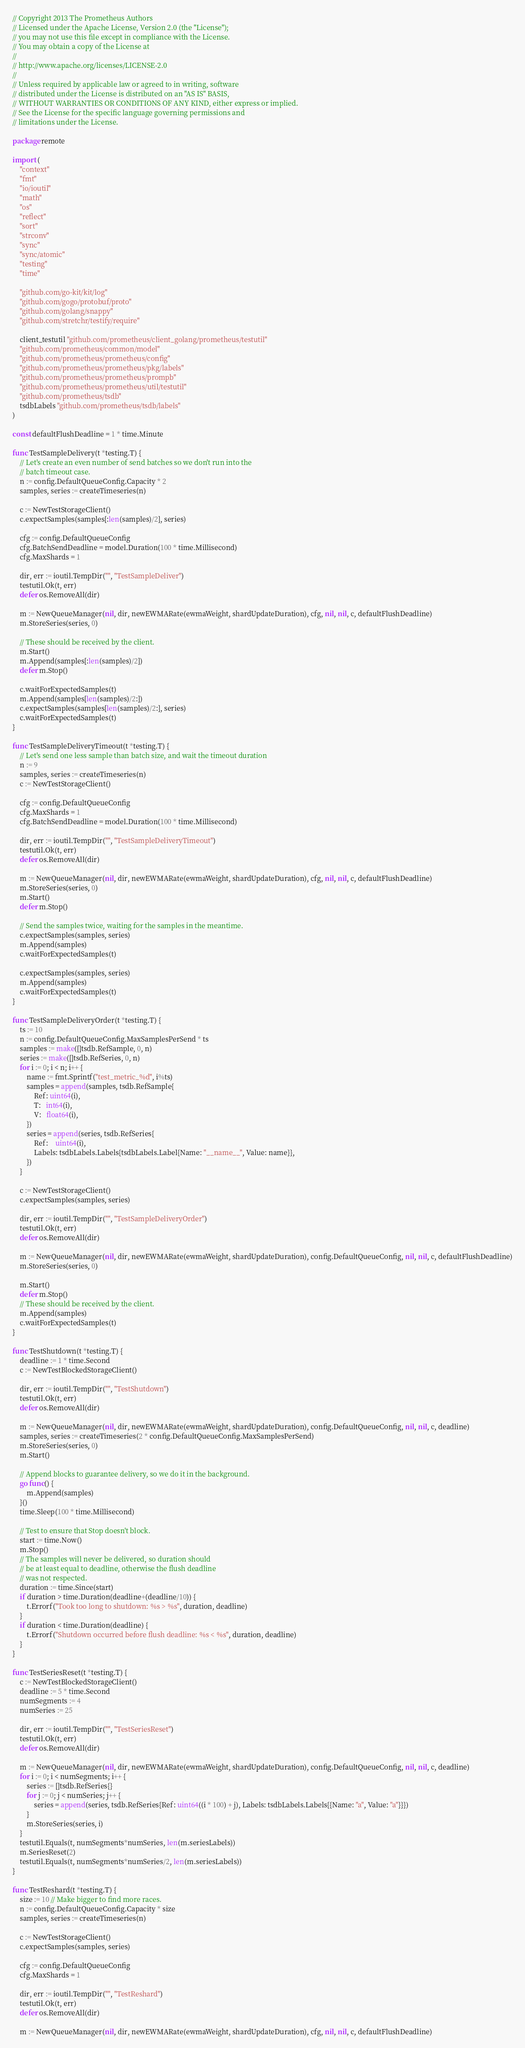<code> <loc_0><loc_0><loc_500><loc_500><_Go_>// Copyright 2013 The Prometheus Authors
// Licensed under the Apache License, Version 2.0 (the "License");
// you may not use this file except in compliance with the License.
// You may obtain a copy of the License at
//
// http://www.apache.org/licenses/LICENSE-2.0
//
// Unless required by applicable law or agreed to in writing, software
// distributed under the License is distributed on an "AS IS" BASIS,
// WITHOUT WARRANTIES OR CONDITIONS OF ANY KIND, either express or implied.
// See the License for the specific language governing permissions and
// limitations under the License.

package remote

import (
	"context"
	"fmt"
	"io/ioutil"
	"math"
	"os"
	"reflect"
	"sort"
	"strconv"
	"sync"
	"sync/atomic"
	"testing"
	"time"

	"github.com/go-kit/kit/log"
	"github.com/gogo/protobuf/proto"
	"github.com/golang/snappy"
	"github.com/stretchr/testify/require"

	client_testutil "github.com/prometheus/client_golang/prometheus/testutil"
	"github.com/prometheus/common/model"
	"github.com/prometheus/prometheus/config"
	"github.com/prometheus/prometheus/pkg/labels"
	"github.com/prometheus/prometheus/prompb"
	"github.com/prometheus/prometheus/util/testutil"
	"github.com/prometheus/tsdb"
	tsdbLabels "github.com/prometheus/tsdb/labels"
)

const defaultFlushDeadline = 1 * time.Minute

func TestSampleDelivery(t *testing.T) {
	// Let's create an even number of send batches so we don't run into the
	// batch timeout case.
	n := config.DefaultQueueConfig.Capacity * 2
	samples, series := createTimeseries(n)

	c := NewTestStorageClient()
	c.expectSamples(samples[:len(samples)/2], series)

	cfg := config.DefaultQueueConfig
	cfg.BatchSendDeadline = model.Duration(100 * time.Millisecond)
	cfg.MaxShards = 1

	dir, err := ioutil.TempDir("", "TestSampleDeliver")
	testutil.Ok(t, err)
	defer os.RemoveAll(dir)

	m := NewQueueManager(nil, dir, newEWMARate(ewmaWeight, shardUpdateDuration), cfg, nil, nil, c, defaultFlushDeadline)
	m.StoreSeries(series, 0)

	// These should be received by the client.
	m.Start()
	m.Append(samples[:len(samples)/2])
	defer m.Stop()

	c.waitForExpectedSamples(t)
	m.Append(samples[len(samples)/2:])
	c.expectSamples(samples[len(samples)/2:], series)
	c.waitForExpectedSamples(t)
}

func TestSampleDeliveryTimeout(t *testing.T) {
	// Let's send one less sample than batch size, and wait the timeout duration
	n := 9
	samples, series := createTimeseries(n)
	c := NewTestStorageClient()

	cfg := config.DefaultQueueConfig
	cfg.MaxShards = 1
	cfg.BatchSendDeadline = model.Duration(100 * time.Millisecond)

	dir, err := ioutil.TempDir("", "TestSampleDeliveryTimeout")
	testutil.Ok(t, err)
	defer os.RemoveAll(dir)

	m := NewQueueManager(nil, dir, newEWMARate(ewmaWeight, shardUpdateDuration), cfg, nil, nil, c, defaultFlushDeadline)
	m.StoreSeries(series, 0)
	m.Start()
	defer m.Stop()

	// Send the samples twice, waiting for the samples in the meantime.
	c.expectSamples(samples, series)
	m.Append(samples)
	c.waitForExpectedSamples(t)

	c.expectSamples(samples, series)
	m.Append(samples)
	c.waitForExpectedSamples(t)
}

func TestSampleDeliveryOrder(t *testing.T) {
	ts := 10
	n := config.DefaultQueueConfig.MaxSamplesPerSend * ts
	samples := make([]tsdb.RefSample, 0, n)
	series := make([]tsdb.RefSeries, 0, n)
	for i := 0; i < n; i++ {
		name := fmt.Sprintf("test_metric_%d", i%ts)
		samples = append(samples, tsdb.RefSample{
			Ref: uint64(i),
			T:   int64(i),
			V:   float64(i),
		})
		series = append(series, tsdb.RefSeries{
			Ref:    uint64(i),
			Labels: tsdbLabels.Labels{tsdbLabels.Label{Name: "__name__", Value: name}},
		})
	}

	c := NewTestStorageClient()
	c.expectSamples(samples, series)

	dir, err := ioutil.TempDir("", "TestSampleDeliveryOrder")
	testutil.Ok(t, err)
	defer os.RemoveAll(dir)

	m := NewQueueManager(nil, dir, newEWMARate(ewmaWeight, shardUpdateDuration), config.DefaultQueueConfig, nil, nil, c, defaultFlushDeadline)
	m.StoreSeries(series, 0)

	m.Start()
	defer m.Stop()
	// These should be received by the client.
	m.Append(samples)
	c.waitForExpectedSamples(t)
}

func TestShutdown(t *testing.T) {
	deadline := 1 * time.Second
	c := NewTestBlockedStorageClient()

	dir, err := ioutil.TempDir("", "TestShutdown")
	testutil.Ok(t, err)
	defer os.RemoveAll(dir)

	m := NewQueueManager(nil, dir, newEWMARate(ewmaWeight, shardUpdateDuration), config.DefaultQueueConfig, nil, nil, c, deadline)
	samples, series := createTimeseries(2 * config.DefaultQueueConfig.MaxSamplesPerSend)
	m.StoreSeries(series, 0)
	m.Start()

	// Append blocks to guarantee delivery, so we do it in the background.
	go func() {
		m.Append(samples)
	}()
	time.Sleep(100 * time.Millisecond)

	// Test to ensure that Stop doesn't block.
	start := time.Now()
	m.Stop()
	// The samples will never be delivered, so duration should
	// be at least equal to deadline, otherwise the flush deadline
	// was not respected.
	duration := time.Since(start)
	if duration > time.Duration(deadline+(deadline/10)) {
		t.Errorf("Took too long to shutdown: %s > %s", duration, deadline)
	}
	if duration < time.Duration(deadline) {
		t.Errorf("Shutdown occurred before flush deadline: %s < %s", duration, deadline)
	}
}

func TestSeriesReset(t *testing.T) {
	c := NewTestBlockedStorageClient()
	deadline := 5 * time.Second
	numSegments := 4
	numSeries := 25

	dir, err := ioutil.TempDir("", "TestSeriesReset")
	testutil.Ok(t, err)
	defer os.RemoveAll(dir)

	m := NewQueueManager(nil, dir, newEWMARate(ewmaWeight, shardUpdateDuration), config.DefaultQueueConfig, nil, nil, c, deadline)
	for i := 0; i < numSegments; i++ {
		series := []tsdb.RefSeries{}
		for j := 0; j < numSeries; j++ {
			series = append(series, tsdb.RefSeries{Ref: uint64((i * 100) + j), Labels: tsdbLabels.Labels{{Name: "a", Value: "a"}}})
		}
		m.StoreSeries(series, i)
	}
	testutil.Equals(t, numSegments*numSeries, len(m.seriesLabels))
	m.SeriesReset(2)
	testutil.Equals(t, numSegments*numSeries/2, len(m.seriesLabels))
}

func TestReshard(t *testing.T) {
	size := 10 // Make bigger to find more races.
	n := config.DefaultQueueConfig.Capacity * size
	samples, series := createTimeseries(n)

	c := NewTestStorageClient()
	c.expectSamples(samples, series)

	cfg := config.DefaultQueueConfig
	cfg.MaxShards = 1

	dir, err := ioutil.TempDir("", "TestReshard")
	testutil.Ok(t, err)
	defer os.RemoveAll(dir)

	m := NewQueueManager(nil, dir, newEWMARate(ewmaWeight, shardUpdateDuration), cfg, nil, nil, c, defaultFlushDeadline)</code> 